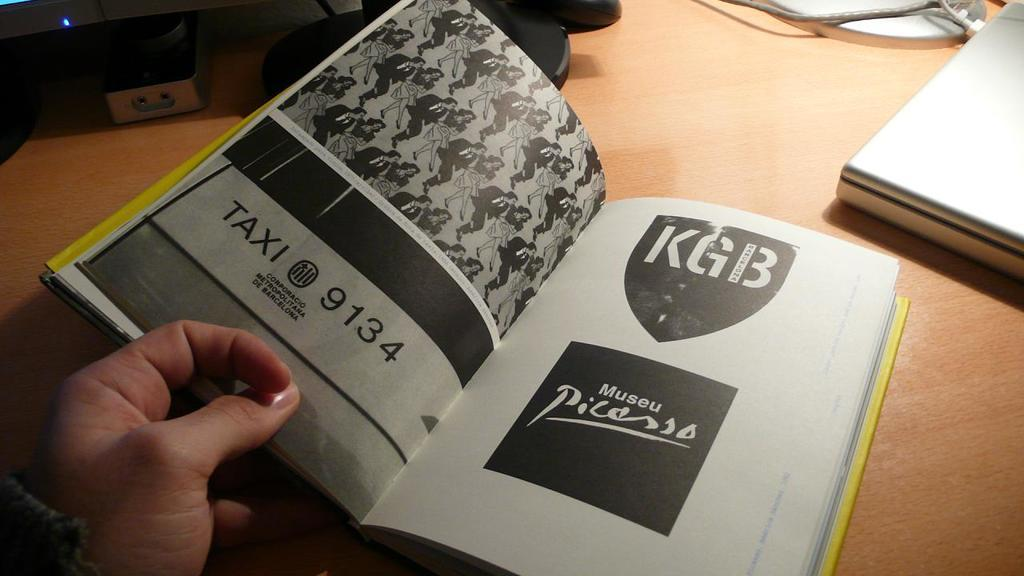<image>
Share a concise interpretation of the image provided. a book someone has open with Taxi 9134, KGB, and Picasso on the pages. 